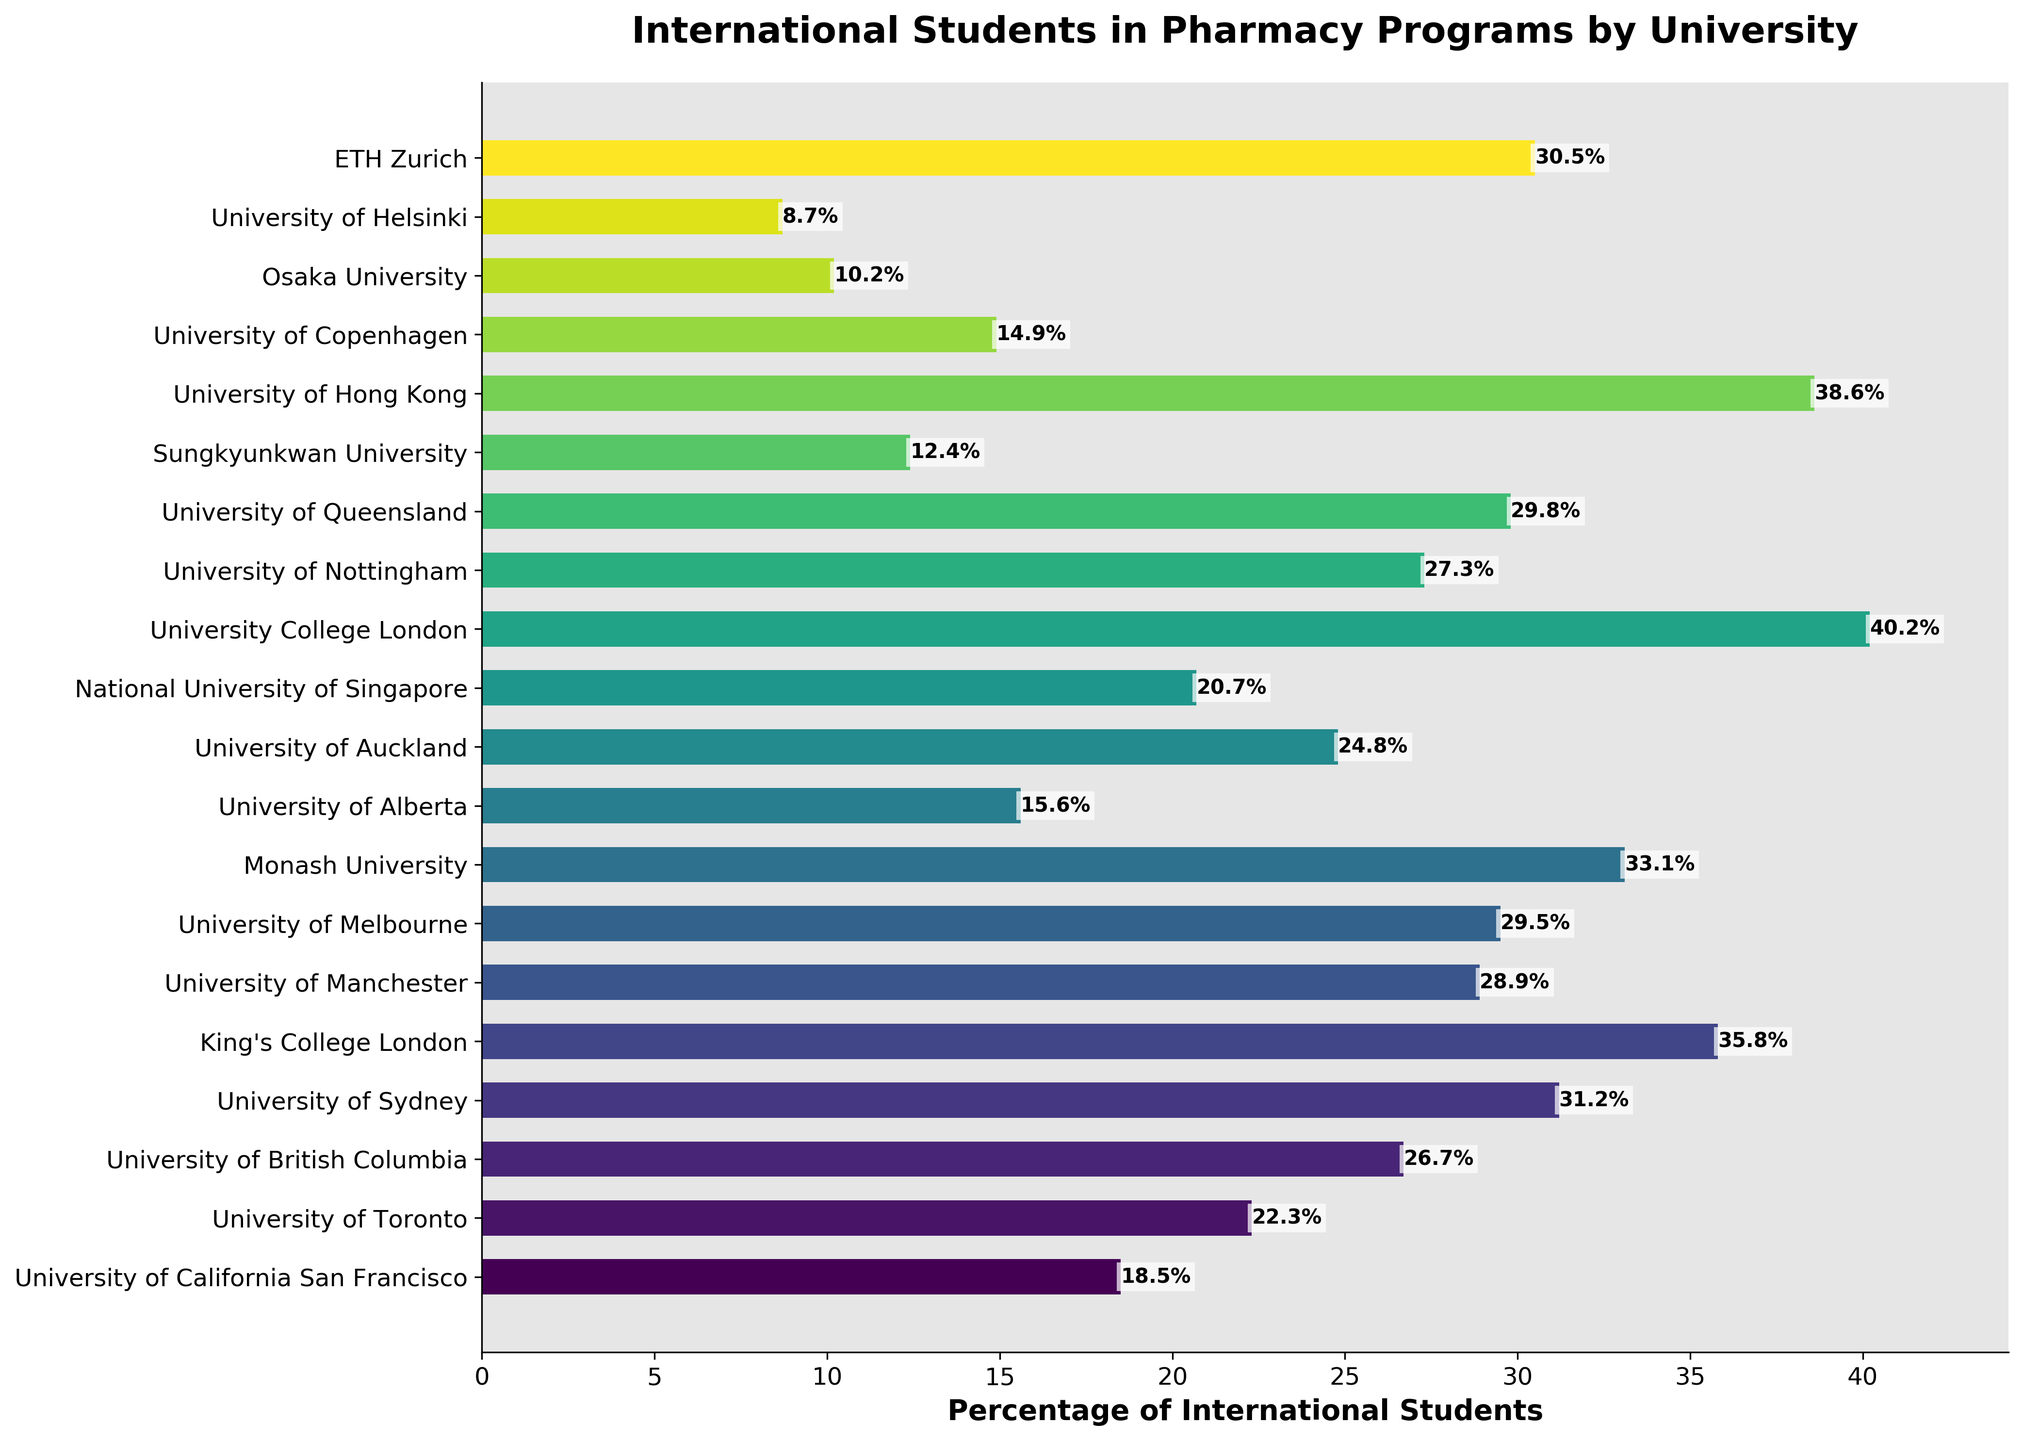What percentage of international students does University College London have in their pharmacy program? University College London is listed as having a particular percentage of international students shown by the length of the bar and the associated value label on the chart.
Answer: 40.2% Which university has the lowest percentage of international students? By scanning the bars from the shortest to the longest and identifying the university with the shortest bar, it can be seen that the shortest bar corresponds to the University of Helsinki.
Answer: University of Helsinki Compare the percentage of international students at University of Melbourne and Monash University. Which one has a higher percentage? Looking at the individual bars for both universities, University of Melbourne has a bar marked with 29.5%, and Monash University has a bar marked with 33.1%.
Answer: Monash University What is the combined percentage of international students at University of Alberta and University of Helsinki? Locate the bars for University of Alberta (15.6%) and University of Helsinki (8.7%), then add their percentages together: 15.6 + 8.7 = 24.3%.
Answer: 24.3% How many universities have a percentage of international students greater than 30%? Count the number of bars that extend past the 30% mark. Those universities are University of Sydney, King's College London, Monash University, University College London, ETH Zurich, and University of Hong Kong, totaling 6 universities.
Answer: 6 Arrange University of Hong Kong, Sungkyunkwan University, and Osaka University in descending order based on their percentage of international students. Identify the values for each: University of Hong Kong (38.6%), Sungkyunkwan University (12.4%), and Osaka University (10.2%). Arrange them from highest to lowest: University of Hong Kong, Sungkyunkwan University, Osaka University.
Answer: University of Hong Kong, Sungkyunkwan University, Osaka University Is the percentage of international students at King's College London more than double that of University of Alberta? Compare the percentage for King's College London (35.8%) to twice the percentage of University of Alberta (2 * 15.6% = 31.2%). Since 35.8% > 31.2%, the percentage of international students at King's College London is more than double that of University of Alberta.
Answer: Yes What is the median percentage of international students among all the universities listed? To find the median, arrange all the universities' percentages in ascending order and locate the middle value (or average the two middle values since there are 19 universities). The sorted percentages are: 8.7, 10.2, 12.4, 14.9, 15.6, 18.5, 20.7, 22.3, 24.8, 26.7, 27.3, 28.9, 29.5, 29.8, 30.5, 31.2, 33.1, 35.8, 38.6, 40.2. The middle (10th and 11th) values are 26.7 and 27.3. So the median is (26.7 + 27.3)/2 = 27.0.
Answer: 27.0 Which universities have less than 20% international students? Identify the bars where the percentage is below 20%: University of Helsinki (8.7%), Osaka University (10.2%), Sungkyunkwan University (12.4%), University of Copenhagen (14.9%), University of Alberta (15.6%), University of California San Francisco (18.5%).
Answer: University of Helsinki, Osaka University, Sungkyunkwan University, University of Copenhagen, University of Alberta, University of California San Francisco Does University of Sydney have a higher percentage of international students compared to National University of Singapore? Compare the percentage for University of Sydney (31.2%) to National University of Singapore (20.7%). Since 31.2% > 20.7%, University of Sydney has a higher percentage.
Answer: Yes 